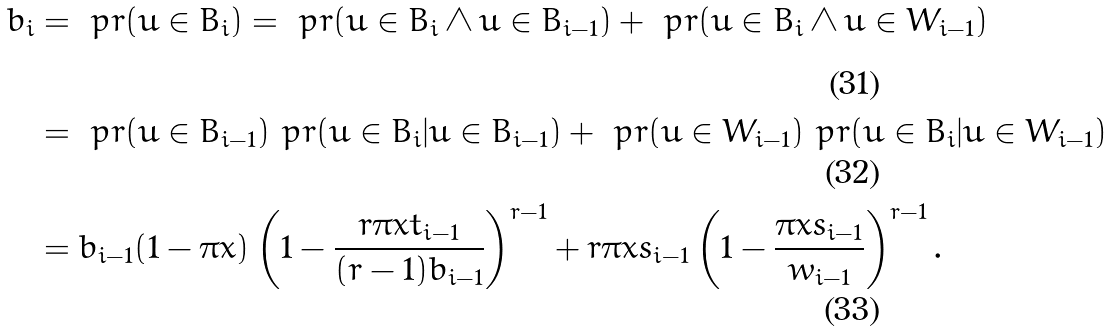<formula> <loc_0><loc_0><loc_500><loc_500>b _ { i } & = \ p r ( u \in B _ { i } ) = \ p r ( u \in B _ { i } \wedge u \in B _ { i - 1 } ) + \ p r ( u \in B _ { i } \wedge u \in W _ { i - 1 } ) \\ & = \ p r ( u \in B _ { i - 1 } ) \ p r ( u \in B _ { i } | u \in B _ { i - 1 } ) + \ p r ( u \in W _ { i - 1 } ) \ p r ( u \in B _ { i } | u \in W _ { i - 1 } ) \\ & = b _ { i - 1 } ( 1 - \pi x ) \left ( 1 - \frac { r \pi x t _ { i - 1 } } { ( r - 1 ) b _ { i - 1 } } \right ) ^ { r - 1 } + r \pi x s _ { i - 1 } \left ( 1 - \frac { \pi x s _ { i - 1 } } { w _ { i - 1 } } \right ) ^ { r - 1 } .</formula> 